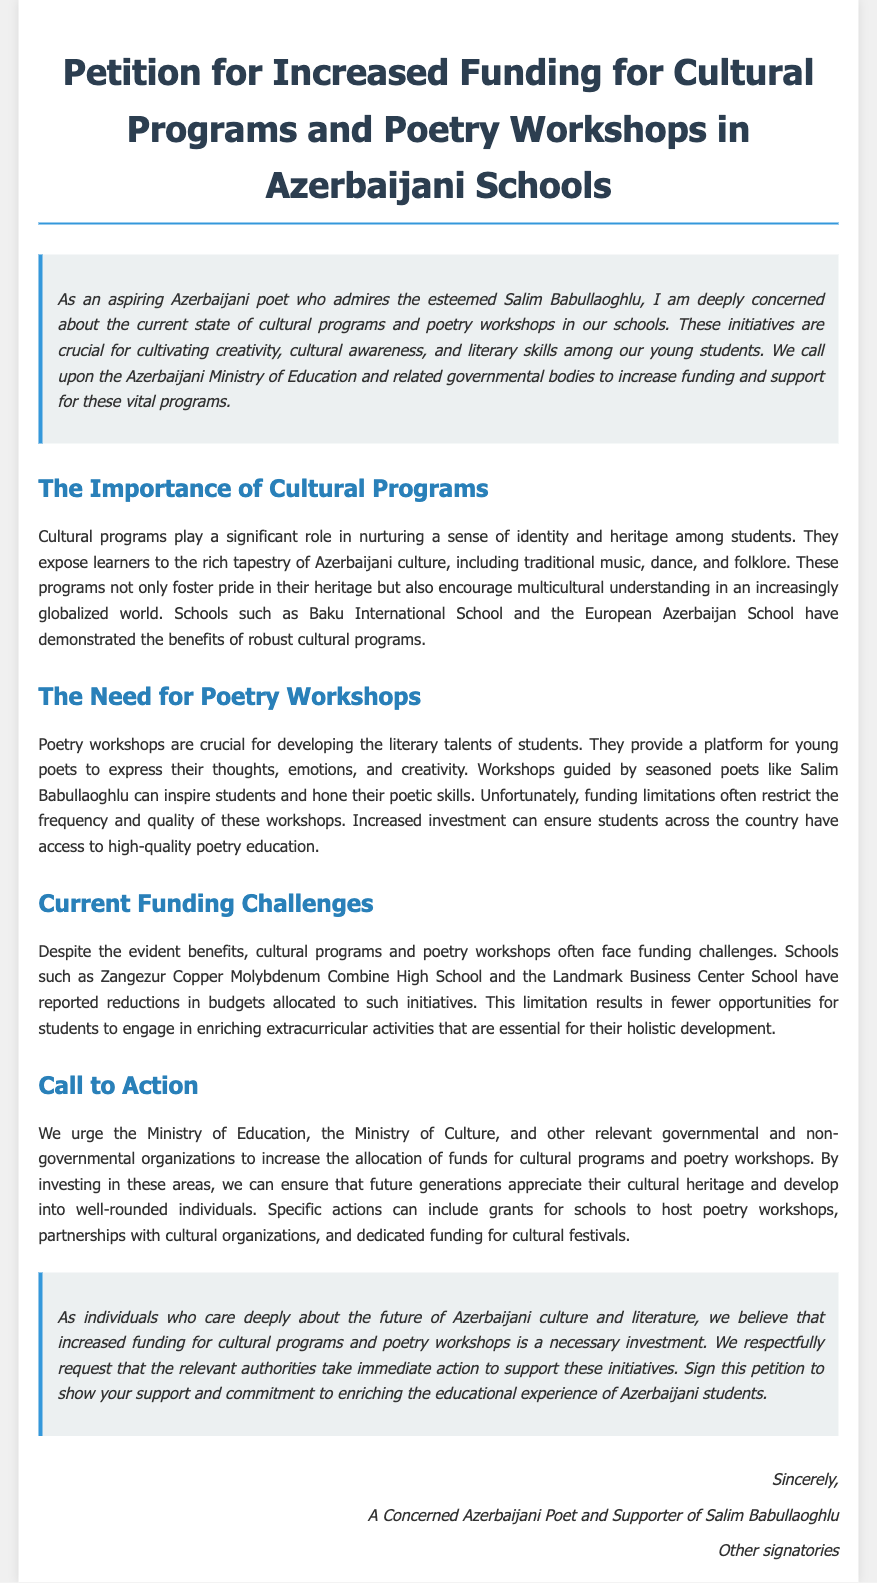What is the title of the petition? The title of the petition is stated prominently at the top of the document.
Answer: Petition for Increased Funding for Cultural Programs and Poetry Workshops in Azerbaijani Schools Who is the esteemed poet mentioned in the introduction? The introduction highlights the admiration for a specific poet, indicating their significance in Azerbaijani literature.
Answer: Salim Babullaoghlu What is the main call to action in the document? The document contains a specific request directed at authorities regarding funding.
Answer: Increase the allocation of funds Which schools are mentioned as examples of the benefits of cultural programs? The document cites specific educational institutions to illustrate successful cultural programs.
Answer: Baku International School and the European Azerbaijan School What are poetry workshops described as crucial for? The document outlines the essential purpose of poetry workshops within the educational context.
Answer: Developing the literary talents of students Which governmental bodies are urged to take action in the petition? The petition specifies certain governmental entities to which the request for action is directed.
Answer: Ministry of Education and Ministry of Culture 